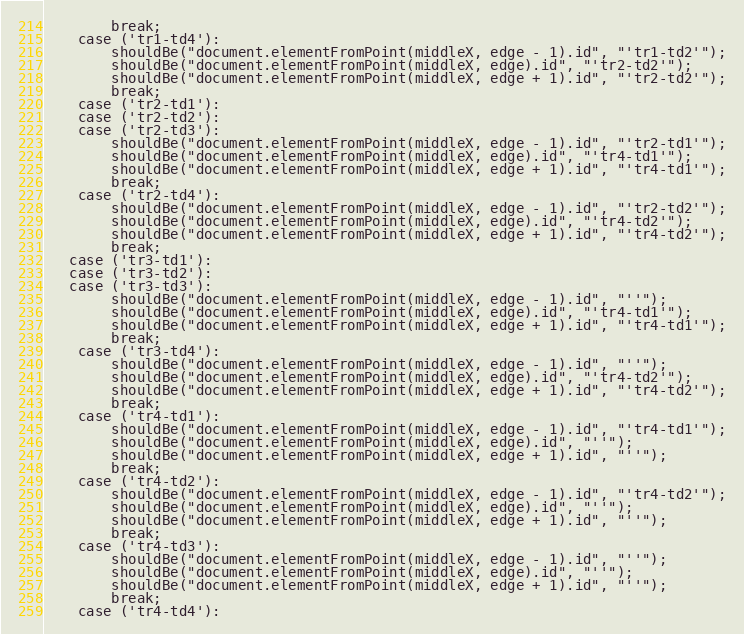<code> <loc_0><loc_0><loc_500><loc_500><_HTML_>		break;
	case ('tr1-td4'):
		shouldBe("document.elementFromPoint(middleX, edge - 1).id", "'tr1-td2'");
		shouldBe("document.elementFromPoint(middleX, edge).id", "'tr2-td2'");
		shouldBe("document.elementFromPoint(middleX, edge + 1).id", "'tr2-td2'");
		break;
	case ('tr2-td1'):
	case ('tr2-td2'): 
	case ('tr2-td3'):                
		shouldBe("document.elementFromPoint(middleX, edge - 1).id", "'tr2-td1'");
		shouldBe("document.elementFromPoint(middleX, edge).id", "'tr4-td1'");
		shouldBe("document.elementFromPoint(middleX, edge + 1).id", "'tr4-td1'");
		break;
	case ('tr2-td4'):
		shouldBe("document.elementFromPoint(middleX, edge - 1).id", "'tr2-td2'");
		shouldBe("document.elementFromPoint(middleX, edge).id", "'tr4-td2'");
		shouldBe("document.elementFromPoint(middleX, edge + 1).id", "'tr4-td2'");
		break;
   case ('tr3-td1'):
   case ('tr3-td2'):
   case ('tr3-td3'):              
		shouldBe("document.elementFromPoint(middleX, edge - 1).id", "''");
		shouldBe("document.elementFromPoint(middleX, edge).id", "'tr4-td1'");
		shouldBe("document.elementFromPoint(middleX, edge + 1).id", "'tr4-td1'");
		break;
	case ('tr3-td4'):
		shouldBe("document.elementFromPoint(middleX, edge - 1).id", "''");
		shouldBe("document.elementFromPoint(middleX, edge).id", "'tr4-td2'");
		shouldBe("document.elementFromPoint(middleX, edge + 1).id", "'tr4-td2'");
		break;
	case ('tr4-td1'):
		shouldBe("document.elementFromPoint(middleX, edge - 1).id", "'tr4-td1'");
		shouldBe("document.elementFromPoint(middleX, edge).id", "''");
		shouldBe("document.elementFromPoint(middleX, edge + 1).id", "''");
		break;
	case ('tr4-td2'):
		shouldBe("document.elementFromPoint(middleX, edge - 1).id", "'tr4-td2'");
		shouldBe("document.elementFromPoint(middleX, edge).id", "''");
		shouldBe("document.elementFromPoint(middleX, edge + 1).id", "''");
		break;        
	case ('tr4-td3'):        
		shouldBe("document.elementFromPoint(middleX, edge - 1).id", "''");
		shouldBe("document.elementFromPoint(middleX, edge).id", "''");
		shouldBe("document.elementFromPoint(middleX, edge + 1).id", "''");
		break;
	case ('tr4-td4'):</code> 